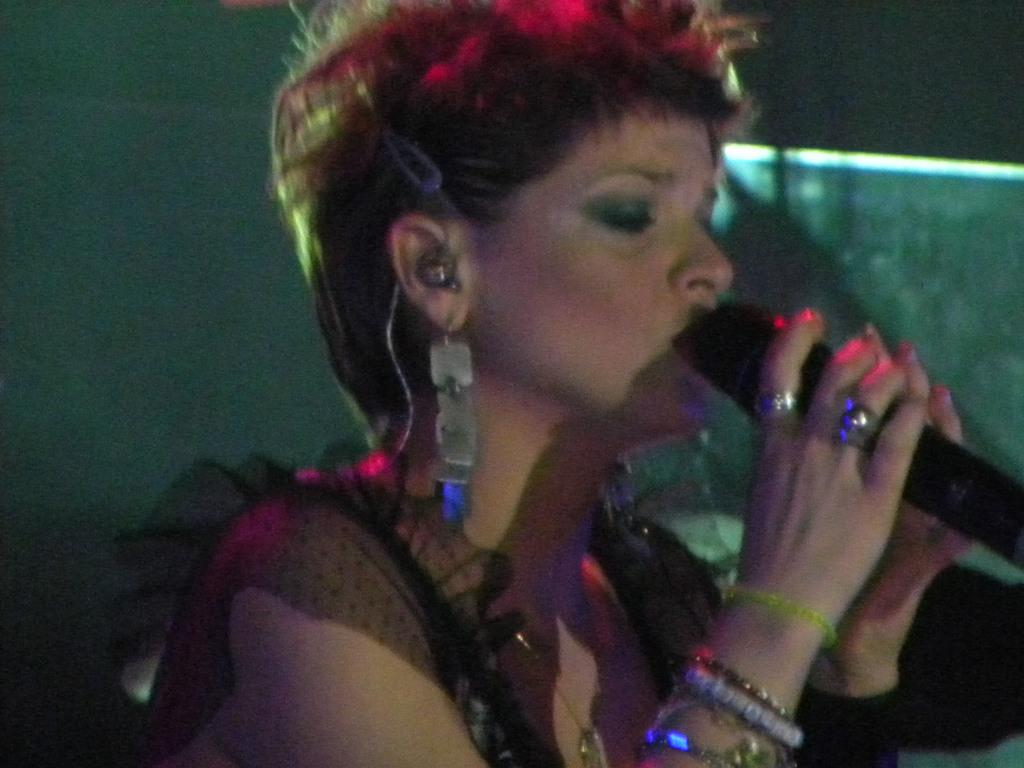What is the main subject of the image? The main subject of the image is a lady. What is the lady holding in the image? The lady is holding a microphone. What can be seen in the background of the image? There is a wall in the background of the image. What type of theory is the lady discussing with the writer in the image? There is no writer or discussion of a theory present in the image; the lady is simply holding a microphone. Can you tell me how many gloves are visible in the image? There are no gloves present in the image. 